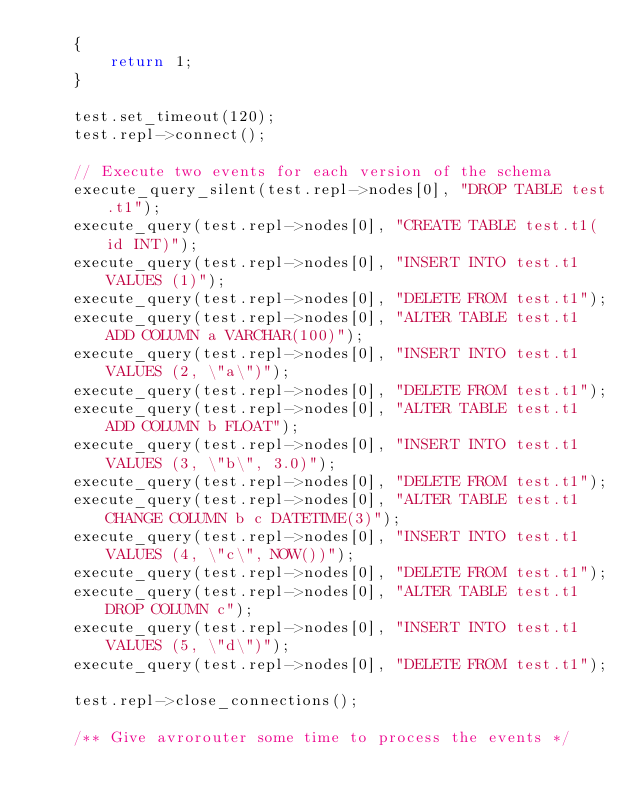Convert code to text. <code><loc_0><loc_0><loc_500><loc_500><_C++_>    {
        return 1;
    }

    test.set_timeout(120);
    test.repl->connect();

    // Execute two events for each version of the schema
    execute_query_silent(test.repl->nodes[0], "DROP TABLE test.t1");
    execute_query(test.repl->nodes[0], "CREATE TABLE test.t1(id INT)");
    execute_query(test.repl->nodes[0], "INSERT INTO test.t1 VALUES (1)");
    execute_query(test.repl->nodes[0], "DELETE FROM test.t1");
    execute_query(test.repl->nodes[0], "ALTER TABLE test.t1 ADD COLUMN a VARCHAR(100)");
    execute_query(test.repl->nodes[0], "INSERT INTO test.t1 VALUES (2, \"a\")");
    execute_query(test.repl->nodes[0], "DELETE FROM test.t1");
    execute_query(test.repl->nodes[0], "ALTER TABLE test.t1 ADD COLUMN b FLOAT");
    execute_query(test.repl->nodes[0], "INSERT INTO test.t1 VALUES (3, \"b\", 3.0)");
    execute_query(test.repl->nodes[0], "DELETE FROM test.t1");
    execute_query(test.repl->nodes[0], "ALTER TABLE test.t1 CHANGE COLUMN b c DATETIME(3)");
    execute_query(test.repl->nodes[0], "INSERT INTO test.t1 VALUES (4, \"c\", NOW())");
    execute_query(test.repl->nodes[0], "DELETE FROM test.t1");
    execute_query(test.repl->nodes[0], "ALTER TABLE test.t1 DROP COLUMN c");
    execute_query(test.repl->nodes[0], "INSERT INTO test.t1 VALUES (5, \"d\")");
    execute_query(test.repl->nodes[0], "DELETE FROM test.t1");

    test.repl->close_connections();

    /** Give avrorouter some time to process the events */</code> 